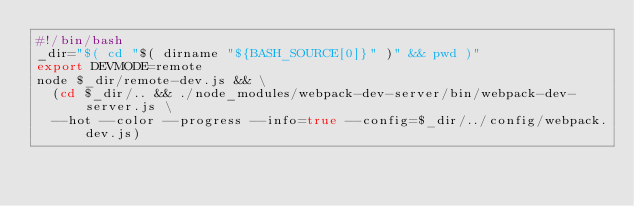<code> <loc_0><loc_0><loc_500><loc_500><_Bash_>#!/bin/bash
_dir="$( cd "$( dirname "${BASH_SOURCE[0]}" )" && pwd )"
export DEVMODE=remote
node $_dir/remote-dev.js && \
  (cd $_dir/.. && ./node_modules/webpack-dev-server/bin/webpack-dev-server.js \
  --hot --color --progress --info=true --config=$_dir/../config/webpack.dev.js)
</code> 